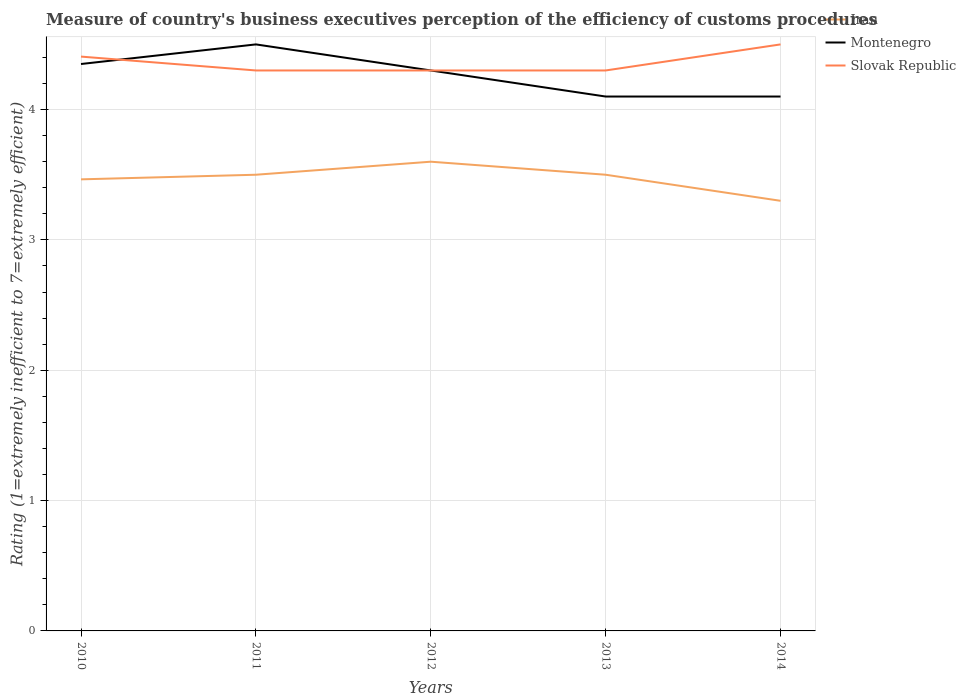In which year was the rating of the efficiency of customs procedure in Montenegro maximum?
Provide a succinct answer. 2013. What is the total rating of the efficiency of customs procedure in Montenegro in the graph?
Your answer should be very brief. 0.05. What is the difference between the highest and the second highest rating of the efficiency of customs procedure in Montenegro?
Your answer should be compact. 0.4. How many years are there in the graph?
Your answer should be compact. 5. Are the values on the major ticks of Y-axis written in scientific E-notation?
Your answer should be very brief. No. What is the title of the graph?
Provide a succinct answer. Measure of country's business executives perception of the efficiency of customs procedures. Does "El Salvador" appear as one of the legend labels in the graph?
Provide a succinct answer. No. What is the label or title of the Y-axis?
Your response must be concise. Rating (1=extremely inefficient to 7=extremely efficient). What is the Rating (1=extremely inefficient to 7=extremely efficient) in Iran in 2010?
Your answer should be compact. 3.46. What is the Rating (1=extremely inefficient to 7=extremely efficient) of Montenegro in 2010?
Your answer should be compact. 4.35. What is the Rating (1=extremely inefficient to 7=extremely efficient) in Slovak Republic in 2010?
Offer a terse response. 4.41. What is the Rating (1=extremely inefficient to 7=extremely efficient) of Montenegro in 2011?
Provide a short and direct response. 4.5. What is the Rating (1=extremely inefficient to 7=extremely efficient) of Slovak Republic in 2011?
Provide a succinct answer. 4.3. What is the Rating (1=extremely inefficient to 7=extremely efficient) in Iran in 2012?
Your response must be concise. 3.6. What is the Rating (1=extremely inefficient to 7=extremely efficient) of Montenegro in 2012?
Offer a very short reply. 4.3. What is the Rating (1=extremely inefficient to 7=extremely efficient) of Slovak Republic in 2012?
Your answer should be compact. 4.3. What is the Rating (1=extremely inefficient to 7=extremely efficient) in Iran in 2013?
Offer a very short reply. 3.5. What is the Rating (1=extremely inefficient to 7=extremely efficient) in Montenegro in 2013?
Keep it short and to the point. 4.1. What is the Rating (1=extremely inefficient to 7=extremely efficient) in Iran in 2014?
Your answer should be very brief. 3.3. Across all years, what is the maximum Rating (1=extremely inefficient to 7=extremely efficient) in Iran?
Make the answer very short. 3.6. Across all years, what is the minimum Rating (1=extremely inefficient to 7=extremely efficient) in Slovak Republic?
Provide a succinct answer. 4.3. What is the total Rating (1=extremely inefficient to 7=extremely efficient) in Iran in the graph?
Your response must be concise. 17.36. What is the total Rating (1=extremely inefficient to 7=extremely efficient) of Montenegro in the graph?
Offer a terse response. 21.35. What is the total Rating (1=extremely inefficient to 7=extremely efficient) in Slovak Republic in the graph?
Keep it short and to the point. 21.81. What is the difference between the Rating (1=extremely inefficient to 7=extremely efficient) in Iran in 2010 and that in 2011?
Make the answer very short. -0.04. What is the difference between the Rating (1=extremely inefficient to 7=extremely efficient) in Montenegro in 2010 and that in 2011?
Provide a succinct answer. -0.15. What is the difference between the Rating (1=extremely inefficient to 7=extremely efficient) of Slovak Republic in 2010 and that in 2011?
Provide a succinct answer. 0.11. What is the difference between the Rating (1=extremely inefficient to 7=extremely efficient) in Iran in 2010 and that in 2012?
Keep it short and to the point. -0.14. What is the difference between the Rating (1=extremely inefficient to 7=extremely efficient) in Montenegro in 2010 and that in 2012?
Give a very brief answer. 0.05. What is the difference between the Rating (1=extremely inefficient to 7=extremely efficient) in Slovak Republic in 2010 and that in 2012?
Ensure brevity in your answer.  0.11. What is the difference between the Rating (1=extremely inefficient to 7=extremely efficient) in Iran in 2010 and that in 2013?
Make the answer very short. -0.04. What is the difference between the Rating (1=extremely inefficient to 7=extremely efficient) of Montenegro in 2010 and that in 2013?
Your answer should be very brief. 0.25. What is the difference between the Rating (1=extremely inefficient to 7=extremely efficient) in Slovak Republic in 2010 and that in 2013?
Give a very brief answer. 0.11. What is the difference between the Rating (1=extremely inefficient to 7=extremely efficient) of Iran in 2010 and that in 2014?
Your answer should be very brief. 0.16. What is the difference between the Rating (1=extremely inefficient to 7=extremely efficient) of Montenegro in 2010 and that in 2014?
Ensure brevity in your answer.  0.25. What is the difference between the Rating (1=extremely inefficient to 7=extremely efficient) in Slovak Republic in 2010 and that in 2014?
Make the answer very short. -0.09. What is the difference between the Rating (1=extremely inefficient to 7=extremely efficient) of Montenegro in 2011 and that in 2012?
Provide a succinct answer. 0.2. What is the difference between the Rating (1=extremely inefficient to 7=extremely efficient) in Slovak Republic in 2011 and that in 2013?
Your answer should be compact. 0. What is the difference between the Rating (1=extremely inefficient to 7=extremely efficient) of Montenegro in 2012 and that in 2013?
Offer a very short reply. 0.2. What is the difference between the Rating (1=extremely inefficient to 7=extremely efficient) of Iran in 2012 and that in 2014?
Offer a very short reply. 0.3. What is the difference between the Rating (1=extremely inefficient to 7=extremely efficient) in Iran in 2013 and that in 2014?
Ensure brevity in your answer.  0.2. What is the difference between the Rating (1=extremely inefficient to 7=extremely efficient) in Iran in 2010 and the Rating (1=extremely inefficient to 7=extremely efficient) in Montenegro in 2011?
Your answer should be compact. -1.04. What is the difference between the Rating (1=extremely inefficient to 7=extremely efficient) of Iran in 2010 and the Rating (1=extremely inefficient to 7=extremely efficient) of Slovak Republic in 2011?
Provide a short and direct response. -0.84. What is the difference between the Rating (1=extremely inefficient to 7=extremely efficient) of Montenegro in 2010 and the Rating (1=extremely inefficient to 7=extremely efficient) of Slovak Republic in 2011?
Ensure brevity in your answer.  0.05. What is the difference between the Rating (1=extremely inefficient to 7=extremely efficient) of Iran in 2010 and the Rating (1=extremely inefficient to 7=extremely efficient) of Montenegro in 2012?
Offer a very short reply. -0.84. What is the difference between the Rating (1=extremely inefficient to 7=extremely efficient) of Iran in 2010 and the Rating (1=extremely inefficient to 7=extremely efficient) of Slovak Republic in 2012?
Your answer should be compact. -0.84. What is the difference between the Rating (1=extremely inefficient to 7=extremely efficient) in Montenegro in 2010 and the Rating (1=extremely inefficient to 7=extremely efficient) in Slovak Republic in 2012?
Keep it short and to the point. 0.05. What is the difference between the Rating (1=extremely inefficient to 7=extremely efficient) of Iran in 2010 and the Rating (1=extremely inefficient to 7=extremely efficient) of Montenegro in 2013?
Provide a succinct answer. -0.64. What is the difference between the Rating (1=extremely inefficient to 7=extremely efficient) in Iran in 2010 and the Rating (1=extremely inefficient to 7=extremely efficient) in Slovak Republic in 2013?
Your answer should be very brief. -0.84. What is the difference between the Rating (1=extremely inefficient to 7=extremely efficient) of Montenegro in 2010 and the Rating (1=extremely inefficient to 7=extremely efficient) of Slovak Republic in 2013?
Provide a succinct answer. 0.05. What is the difference between the Rating (1=extremely inefficient to 7=extremely efficient) in Iran in 2010 and the Rating (1=extremely inefficient to 7=extremely efficient) in Montenegro in 2014?
Your answer should be compact. -0.64. What is the difference between the Rating (1=extremely inefficient to 7=extremely efficient) in Iran in 2010 and the Rating (1=extremely inefficient to 7=extremely efficient) in Slovak Republic in 2014?
Offer a terse response. -1.04. What is the difference between the Rating (1=extremely inefficient to 7=extremely efficient) in Montenegro in 2010 and the Rating (1=extremely inefficient to 7=extremely efficient) in Slovak Republic in 2014?
Keep it short and to the point. -0.15. What is the difference between the Rating (1=extremely inefficient to 7=extremely efficient) in Iran in 2011 and the Rating (1=extremely inefficient to 7=extremely efficient) in Montenegro in 2012?
Give a very brief answer. -0.8. What is the difference between the Rating (1=extremely inefficient to 7=extremely efficient) of Montenegro in 2011 and the Rating (1=extremely inefficient to 7=extremely efficient) of Slovak Republic in 2012?
Offer a terse response. 0.2. What is the difference between the Rating (1=extremely inefficient to 7=extremely efficient) in Iran in 2011 and the Rating (1=extremely inefficient to 7=extremely efficient) in Slovak Republic in 2013?
Your answer should be very brief. -0.8. What is the difference between the Rating (1=extremely inefficient to 7=extremely efficient) of Montenegro in 2011 and the Rating (1=extremely inefficient to 7=extremely efficient) of Slovak Republic in 2013?
Your answer should be compact. 0.2. What is the difference between the Rating (1=extremely inefficient to 7=extremely efficient) of Iran in 2011 and the Rating (1=extremely inefficient to 7=extremely efficient) of Slovak Republic in 2014?
Make the answer very short. -1. What is the difference between the Rating (1=extremely inefficient to 7=extremely efficient) in Iran in 2012 and the Rating (1=extremely inefficient to 7=extremely efficient) in Montenegro in 2014?
Keep it short and to the point. -0.5. What is the difference between the Rating (1=extremely inefficient to 7=extremely efficient) of Iran in 2012 and the Rating (1=extremely inefficient to 7=extremely efficient) of Slovak Republic in 2014?
Provide a short and direct response. -0.9. What is the difference between the Rating (1=extremely inefficient to 7=extremely efficient) of Iran in 2013 and the Rating (1=extremely inefficient to 7=extremely efficient) of Montenegro in 2014?
Keep it short and to the point. -0.6. What is the difference between the Rating (1=extremely inefficient to 7=extremely efficient) of Iran in 2013 and the Rating (1=extremely inefficient to 7=extremely efficient) of Slovak Republic in 2014?
Provide a succinct answer. -1. What is the difference between the Rating (1=extremely inefficient to 7=extremely efficient) in Montenegro in 2013 and the Rating (1=extremely inefficient to 7=extremely efficient) in Slovak Republic in 2014?
Make the answer very short. -0.4. What is the average Rating (1=extremely inefficient to 7=extremely efficient) in Iran per year?
Provide a short and direct response. 3.47. What is the average Rating (1=extremely inefficient to 7=extremely efficient) of Montenegro per year?
Your answer should be very brief. 4.27. What is the average Rating (1=extremely inefficient to 7=extremely efficient) of Slovak Republic per year?
Your response must be concise. 4.36. In the year 2010, what is the difference between the Rating (1=extremely inefficient to 7=extremely efficient) in Iran and Rating (1=extremely inefficient to 7=extremely efficient) in Montenegro?
Keep it short and to the point. -0.88. In the year 2010, what is the difference between the Rating (1=extremely inefficient to 7=extremely efficient) of Iran and Rating (1=extremely inefficient to 7=extremely efficient) of Slovak Republic?
Your response must be concise. -0.94. In the year 2010, what is the difference between the Rating (1=extremely inefficient to 7=extremely efficient) of Montenegro and Rating (1=extremely inefficient to 7=extremely efficient) of Slovak Republic?
Keep it short and to the point. -0.06. In the year 2011, what is the difference between the Rating (1=extremely inefficient to 7=extremely efficient) of Iran and Rating (1=extremely inefficient to 7=extremely efficient) of Slovak Republic?
Your response must be concise. -0.8. In the year 2012, what is the difference between the Rating (1=extremely inefficient to 7=extremely efficient) in Iran and Rating (1=extremely inefficient to 7=extremely efficient) in Slovak Republic?
Your answer should be very brief. -0.7. In the year 2012, what is the difference between the Rating (1=extremely inefficient to 7=extremely efficient) of Montenegro and Rating (1=extremely inefficient to 7=extremely efficient) of Slovak Republic?
Give a very brief answer. 0. In the year 2013, what is the difference between the Rating (1=extremely inefficient to 7=extremely efficient) of Iran and Rating (1=extremely inefficient to 7=extremely efficient) of Montenegro?
Offer a terse response. -0.6. In the year 2013, what is the difference between the Rating (1=extremely inefficient to 7=extremely efficient) of Montenegro and Rating (1=extremely inefficient to 7=extremely efficient) of Slovak Republic?
Keep it short and to the point. -0.2. In the year 2014, what is the difference between the Rating (1=extremely inefficient to 7=extremely efficient) in Iran and Rating (1=extremely inefficient to 7=extremely efficient) in Montenegro?
Keep it short and to the point. -0.8. What is the ratio of the Rating (1=extremely inefficient to 7=extremely efficient) in Montenegro in 2010 to that in 2011?
Your answer should be compact. 0.97. What is the ratio of the Rating (1=extremely inefficient to 7=extremely efficient) of Slovak Republic in 2010 to that in 2011?
Ensure brevity in your answer.  1.02. What is the ratio of the Rating (1=extremely inefficient to 7=extremely efficient) in Iran in 2010 to that in 2012?
Make the answer very short. 0.96. What is the ratio of the Rating (1=extremely inefficient to 7=extremely efficient) in Montenegro in 2010 to that in 2012?
Provide a succinct answer. 1.01. What is the ratio of the Rating (1=extremely inefficient to 7=extremely efficient) of Slovak Republic in 2010 to that in 2012?
Your answer should be compact. 1.02. What is the ratio of the Rating (1=extremely inefficient to 7=extremely efficient) in Iran in 2010 to that in 2013?
Your response must be concise. 0.99. What is the ratio of the Rating (1=extremely inefficient to 7=extremely efficient) in Montenegro in 2010 to that in 2013?
Ensure brevity in your answer.  1.06. What is the ratio of the Rating (1=extremely inefficient to 7=extremely efficient) in Slovak Republic in 2010 to that in 2013?
Your response must be concise. 1.02. What is the ratio of the Rating (1=extremely inefficient to 7=extremely efficient) in Iran in 2010 to that in 2014?
Provide a short and direct response. 1.05. What is the ratio of the Rating (1=extremely inefficient to 7=extremely efficient) of Montenegro in 2010 to that in 2014?
Ensure brevity in your answer.  1.06. What is the ratio of the Rating (1=extremely inefficient to 7=extremely efficient) of Slovak Republic in 2010 to that in 2014?
Give a very brief answer. 0.98. What is the ratio of the Rating (1=extremely inefficient to 7=extremely efficient) in Iran in 2011 to that in 2012?
Give a very brief answer. 0.97. What is the ratio of the Rating (1=extremely inefficient to 7=extremely efficient) of Montenegro in 2011 to that in 2012?
Your answer should be compact. 1.05. What is the ratio of the Rating (1=extremely inefficient to 7=extremely efficient) in Iran in 2011 to that in 2013?
Keep it short and to the point. 1. What is the ratio of the Rating (1=extremely inefficient to 7=extremely efficient) in Montenegro in 2011 to that in 2013?
Your answer should be compact. 1.1. What is the ratio of the Rating (1=extremely inefficient to 7=extremely efficient) of Iran in 2011 to that in 2014?
Ensure brevity in your answer.  1.06. What is the ratio of the Rating (1=extremely inefficient to 7=extremely efficient) of Montenegro in 2011 to that in 2014?
Offer a very short reply. 1.1. What is the ratio of the Rating (1=extremely inefficient to 7=extremely efficient) of Slovak Republic in 2011 to that in 2014?
Provide a short and direct response. 0.96. What is the ratio of the Rating (1=extremely inefficient to 7=extremely efficient) of Iran in 2012 to that in 2013?
Offer a very short reply. 1.03. What is the ratio of the Rating (1=extremely inefficient to 7=extremely efficient) in Montenegro in 2012 to that in 2013?
Provide a succinct answer. 1.05. What is the ratio of the Rating (1=extremely inefficient to 7=extremely efficient) of Montenegro in 2012 to that in 2014?
Your response must be concise. 1.05. What is the ratio of the Rating (1=extremely inefficient to 7=extremely efficient) of Slovak Republic in 2012 to that in 2014?
Ensure brevity in your answer.  0.96. What is the ratio of the Rating (1=extremely inefficient to 7=extremely efficient) in Iran in 2013 to that in 2014?
Keep it short and to the point. 1.06. What is the ratio of the Rating (1=extremely inefficient to 7=extremely efficient) of Montenegro in 2013 to that in 2014?
Keep it short and to the point. 1. What is the ratio of the Rating (1=extremely inefficient to 7=extremely efficient) of Slovak Republic in 2013 to that in 2014?
Offer a terse response. 0.96. What is the difference between the highest and the second highest Rating (1=extremely inefficient to 7=extremely efficient) in Iran?
Offer a terse response. 0.1. What is the difference between the highest and the second highest Rating (1=extremely inefficient to 7=extremely efficient) in Montenegro?
Offer a terse response. 0.15. What is the difference between the highest and the second highest Rating (1=extremely inefficient to 7=extremely efficient) of Slovak Republic?
Offer a very short reply. 0.09. What is the difference between the highest and the lowest Rating (1=extremely inefficient to 7=extremely efficient) of Montenegro?
Ensure brevity in your answer.  0.4. What is the difference between the highest and the lowest Rating (1=extremely inefficient to 7=extremely efficient) of Slovak Republic?
Your answer should be compact. 0.2. 